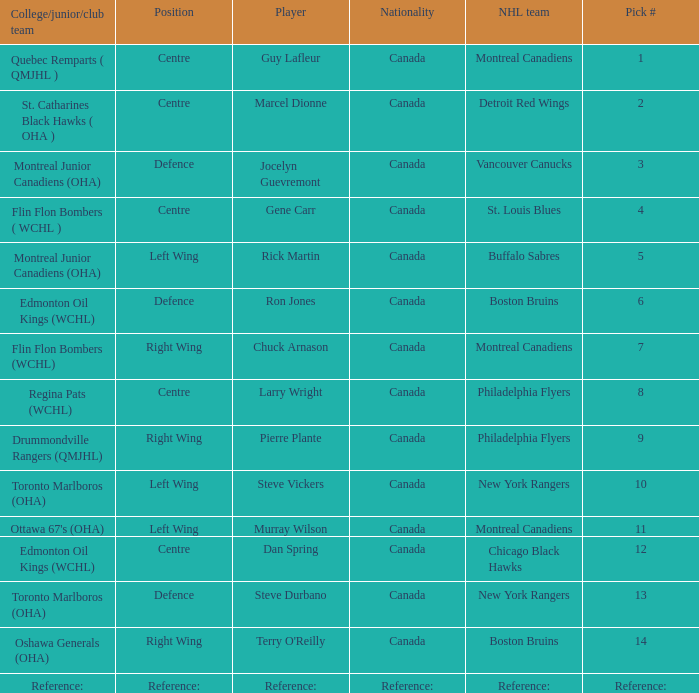Which College/junior/club team has a Pick # of 1? Quebec Remparts ( QMJHL ). 